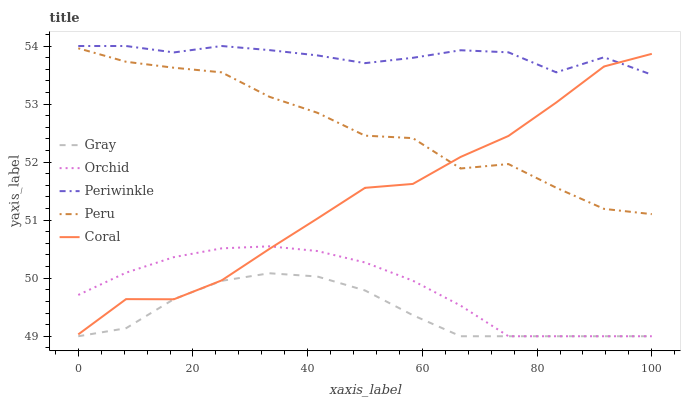Does Gray have the minimum area under the curve?
Answer yes or no. Yes. Does Periwinkle have the maximum area under the curve?
Answer yes or no. Yes. Does Coral have the minimum area under the curve?
Answer yes or no. No. Does Coral have the maximum area under the curve?
Answer yes or no. No. Is Orchid the smoothest?
Answer yes or no. Yes. Is Peru the roughest?
Answer yes or no. Yes. Is Coral the smoothest?
Answer yes or no. No. Is Coral the roughest?
Answer yes or no. No. Does Gray have the lowest value?
Answer yes or no. Yes. Does Coral have the lowest value?
Answer yes or no. No. Does Periwinkle have the highest value?
Answer yes or no. Yes. Does Coral have the highest value?
Answer yes or no. No. Is Orchid less than Peru?
Answer yes or no. Yes. Is Peru greater than Orchid?
Answer yes or no. Yes. Does Coral intersect Orchid?
Answer yes or no. Yes. Is Coral less than Orchid?
Answer yes or no. No. Is Coral greater than Orchid?
Answer yes or no. No. Does Orchid intersect Peru?
Answer yes or no. No. 